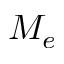<formula> <loc_0><loc_0><loc_500><loc_500>M _ { e }</formula> 